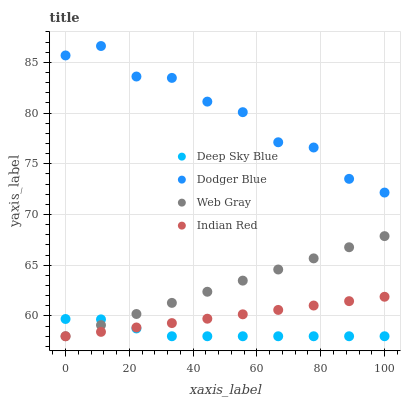Does Deep Sky Blue have the minimum area under the curve?
Answer yes or no. Yes. Does Dodger Blue have the maximum area under the curve?
Answer yes or no. Yes. Does Indian Red have the minimum area under the curve?
Answer yes or no. No. Does Indian Red have the maximum area under the curve?
Answer yes or no. No. Is Indian Red the smoothest?
Answer yes or no. Yes. Is Dodger Blue the roughest?
Answer yes or no. Yes. Is Dodger Blue the smoothest?
Answer yes or no. No. Is Indian Red the roughest?
Answer yes or no. No. Does Web Gray have the lowest value?
Answer yes or no. Yes. Does Dodger Blue have the lowest value?
Answer yes or no. No. Does Dodger Blue have the highest value?
Answer yes or no. Yes. Does Indian Red have the highest value?
Answer yes or no. No. Is Web Gray less than Dodger Blue?
Answer yes or no. Yes. Is Dodger Blue greater than Web Gray?
Answer yes or no. Yes. Does Indian Red intersect Deep Sky Blue?
Answer yes or no. Yes. Is Indian Red less than Deep Sky Blue?
Answer yes or no. No. Is Indian Red greater than Deep Sky Blue?
Answer yes or no. No. Does Web Gray intersect Dodger Blue?
Answer yes or no. No. 